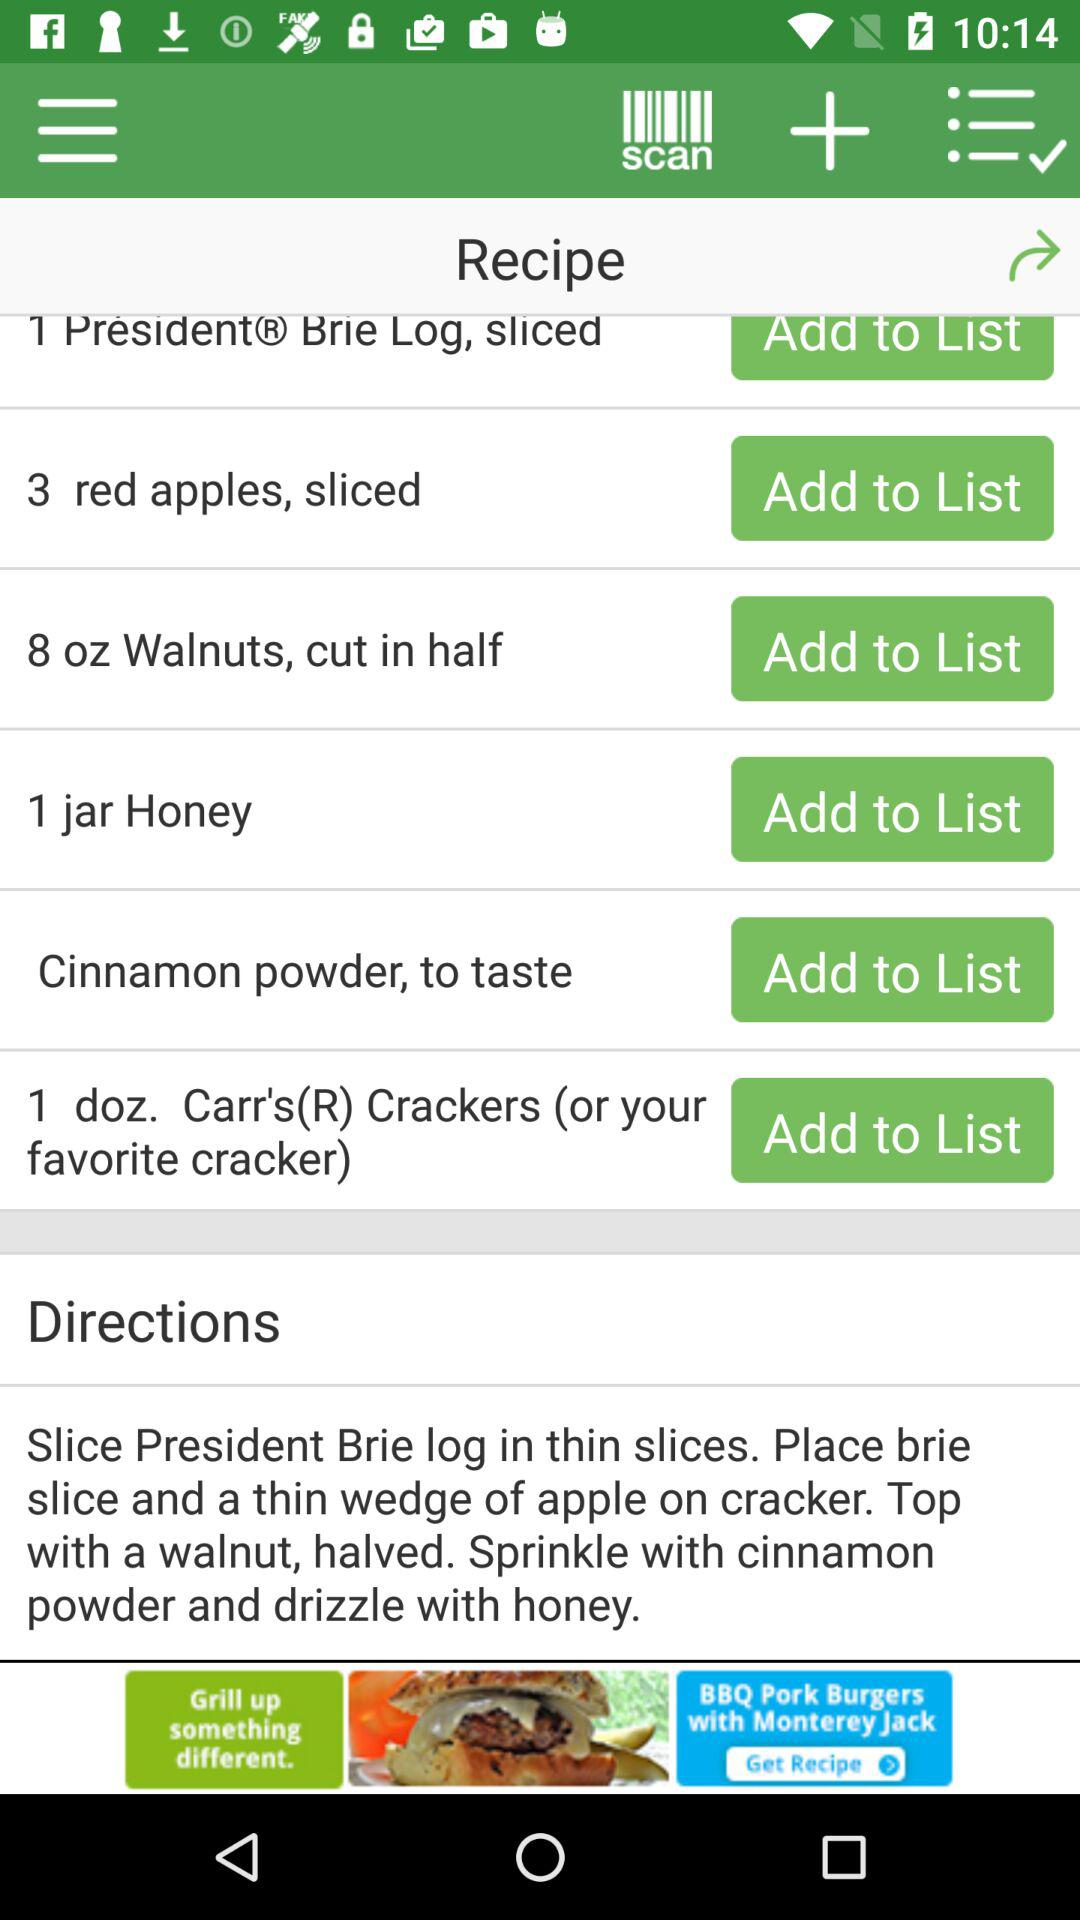What is the used quantity of walnuts? The used quantity of walnuts is 8 oz. 